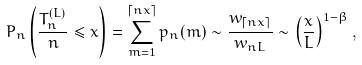<formula> <loc_0><loc_0><loc_500><loc_500>P _ { n } \left ( \frac { T _ { n } ^ { ( L ) } } { n } \leq x \right ) = \sum _ { m = 1 } ^ { \lceil n x \rceil } p _ { n } ( m ) \sim \frac { w _ { \lceil n x \rceil } } { w _ { n L } } \sim \left ( \frac { x } { L } \right ) ^ { 1 - \beta } ,</formula> 